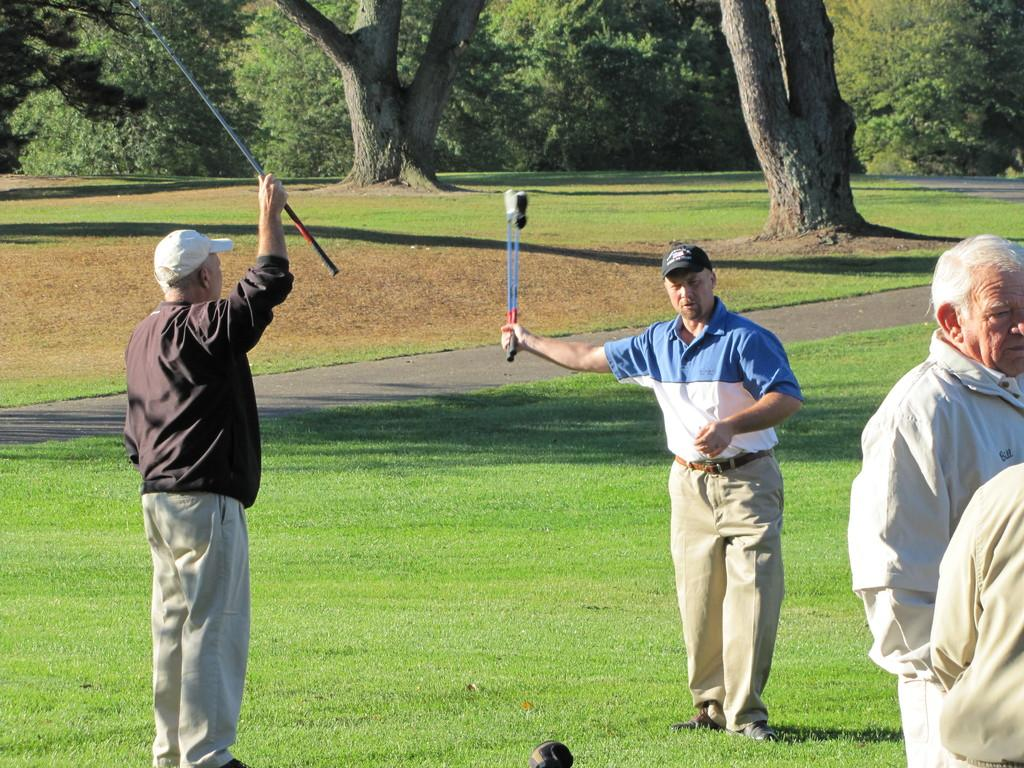How many people are in the image? There is a group of people in the image. What is the setting of the image? The people are standing on a grass field. What are some of the people holding in their hands? Some persons are holding sticks in their hands. What can be seen in the background of the image? There is a group of trees in the background of the image. What type of sign can be seen in the image? There is no sign present in the image. How many cows are visible in the image? There are no cows visible in the image. 